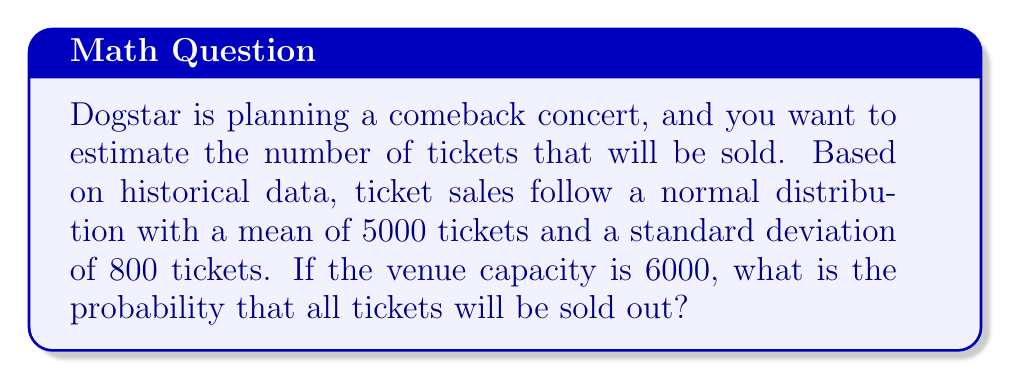Could you help me with this problem? To solve this problem, we need to use the properties of the normal distribution and calculate the z-score for the given scenario. Let's break it down step by step:

1. Given information:
   - Ticket sales follow a normal distribution
   - Mean (μ) = 5000 tickets
   - Standard deviation (σ) = 800 tickets
   - Venue capacity = 6000 tickets

2. We want to find P(X ≥ 6000), where X is the number of tickets sold.

3. Calculate the z-score for 6000 tickets:
   $$ z = \frac{x - \mu}{\sigma} = \frac{6000 - 5000}{800} = \frac{1000}{800} = 1.25 $$

4. The probability of selling out is equivalent to the area under the standard normal curve to the right of z = 1.25.

5. Using a standard normal table or a calculator, we can find that:
   $$ P(Z > 1.25) = 1 - P(Z < 1.25) = 1 - 0.8944 = 0.1056 $$

6. Convert the probability to a percentage:
   $$ 0.1056 \times 100\% = 10.56\% $$

Therefore, the probability that all tickets will be sold out is approximately 10.56%.
Answer: 10.56% 